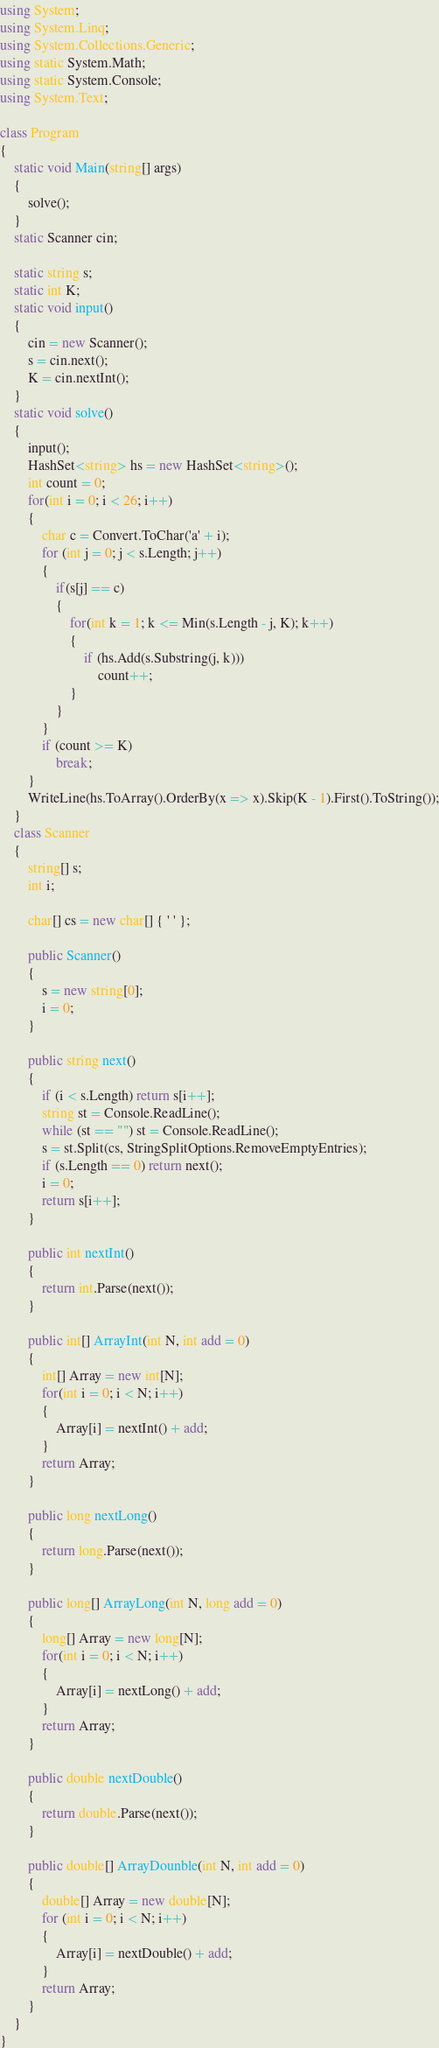<code> <loc_0><loc_0><loc_500><loc_500><_C#_>using System;
using System.Linq;
using System.Collections.Generic;
using static System.Math;
using static System.Console;
using System.Text;

class Program
{
    static void Main(string[] args)
    {
        solve();
    }
    static Scanner cin;

    static string s;
    static int K;
    static void input()
    {
        cin = new Scanner();
        s = cin.next();
        K = cin.nextInt();
    }
    static void solve()
    {
        input();
        HashSet<string> hs = new HashSet<string>();
        int count = 0;
        for(int i = 0; i < 26; i++)
        {
            char c = Convert.ToChar('a' + i);
            for (int j = 0; j < s.Length; j++)
            {
                if(s[j] == c)
                {
                    for(int k = 1; k <= Min(s.Length - j, K); k++)
                    {
                        if (hs.Add(s.Substring(j, k)))
                            count++;
                    }
                }
            }
            if (count >= K)
                break;
        }
        WriteLine(hs.ToArray().OrderBy(x => x).Skip(K - 1).First().ToString());
    }
    class Scanner
    {
        string[] s;
        int i;

        char[] cs = new char[] { ' ' };

        public Scanner()
        {
            s = new string[0];
            i = 0;
        }
        
        public string next()
        {
            if (i < s.Length) return s[i++];
            string st = Console.ReadLine();
            while (st == "") st = Console.ReadLine();
            s = st.Split(cs, StringSplitOptions.RemoveEmptyEntries);
            if (s.Length == 0) return next();
            i = 0;
            return s[i++];
        }

        public int nextInt()
        {
            return int.Parse(next());
        }

        public int[] ArrayInt(int N, int add = 0)
        {
            int[] Array = new int[N];
            for(int i = 0; i < N; i++)
            {
                Array[i] = nextInt() + add;
            }
            return Array;
        }

        public long nextLong()
        {
            return long.Parse(next());
        }

        public long[] ArrayLong(int N, long add = 0)
        {
            long[] Array = new long[N];
            for(int i = 0; i < N; i++)
            {
                Array[i] = nextLong() + add;
            }
            return Array;
        }

        public double nextDouble()
        {
            return double.Parse(next());
        }

        public double[] ArrayDounble(int N, int add = 0)
        {
            double[] Array = new double[N];
            for (int i = 0; i < N; i++)
            {
                Array[i] = nextDouble() + add;
            }
            return Array;
        }
    }
}</code> 